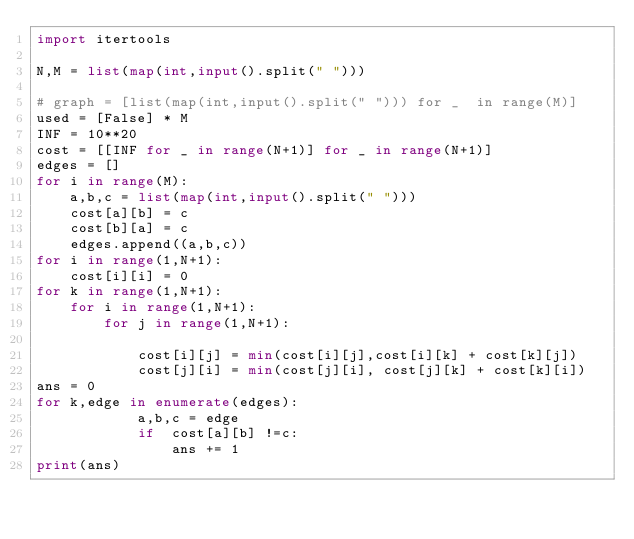<code> <loc_0><loc_0><loc_500><loc_500><_Python_>import itertools

N,M = list(map(int,input().split(" ")))

# graph = [list(map(int,input().split(" "))) for _  in range(M)]
used = [False] * M
INF = 10**20
cost = [[INF for _ in range(N+1)] for _ in range(N+1)]
edges = []
for i in range(M):
    a,b,c = list(map(int,input().split(" ")))
    cost[a][b] = c
    cost[b][a] = c
    edges.append((a,b,c))
for i in range(1,N+1):
    cost[i][i] = 0
for k in range(1,N+1):
    for i in range(1,N+1):
        for j in range(1,N+1):

            cost[i][j] = min(cost[i][j],cost[i][k] + cost[k][j])
            cost[j][i] = min(cost[j][i], cost[j][k] + cost[k][i])
ans = 0
for k,edge in enumerate(edges):
            a,b,c = edge
            if  cost[a][b] !=c:
                ans += 1
print(ans)
</code> 